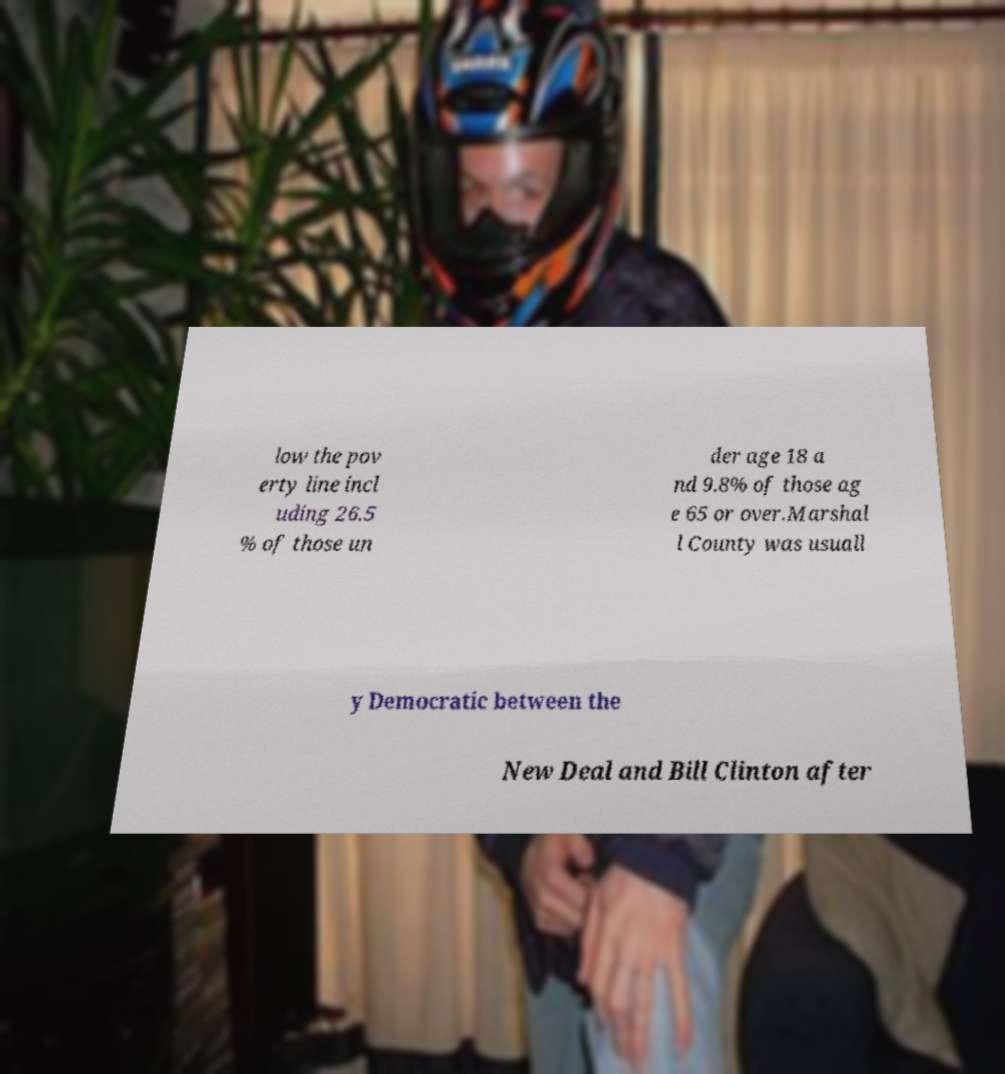For documentation purposes, I need the text within this image transcribed. Could you provide that? low the pov erty line incl uding 26.5 % of those un der age 18 a nd 9.8% of those ag e 65 or over.Marshal l County was usuall y Democratic between the New Deal and Bill Clinton after 